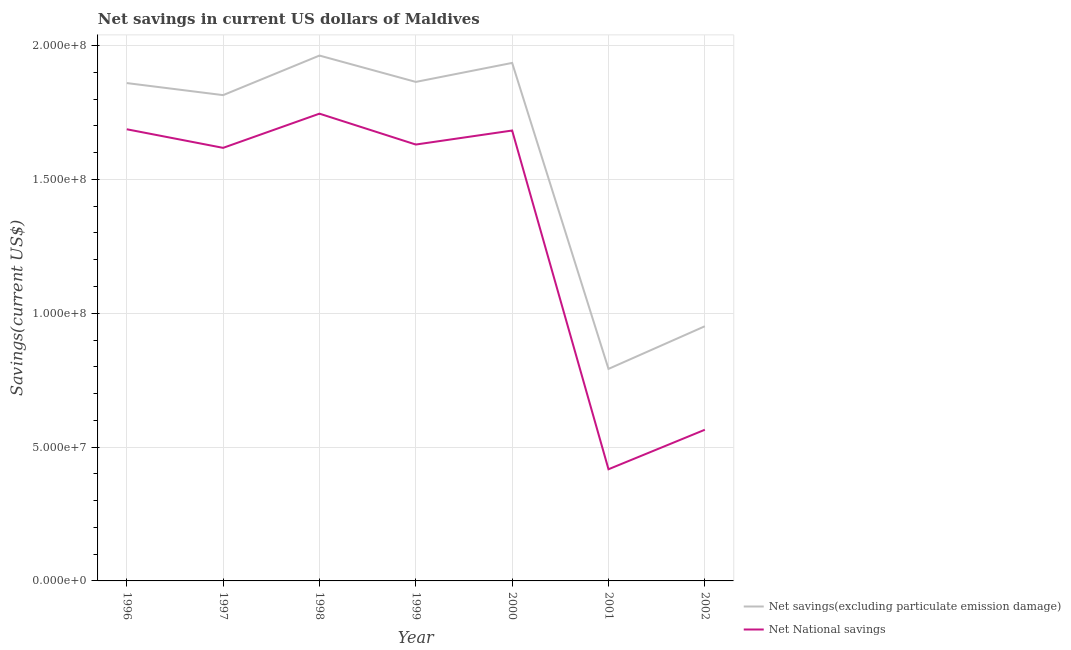Does the line corresponding to net national savings intersect with the line corresponding to net savings(excluding particulate emission damage)?
Offer a very short reply. No. What is the net national savings in 2001?
Offer a very short reply. 4.17e+07. Across all years, what is the maximum net national savings?
Make the answer very short. 1.75e+08. Across all years, what is the minimum net savings(excluding particulate emission damage)?
Your response must be concise. 7.92e+07. What is the total net savings(excluding particulate emission damage) in the graph?
Your answer should be very brief. 1.12e+09. What is the difference between the net savings(excluding particulate emission damage) in 1998 and that in 2000?
Provide a short and direct response. 2.75e+06. What is the difference between the net national savings in 2002 and the net savings(excluding particulate emission damage) in 1999?
Provide a succinct answer. -1.30e+08. What is the average net national savings per year?
Offer a terse response. 1.34e+08. In the year 2000, what is the difference between the net national savings and net savings(excluding particulate emission damage)?
Keep it short and to the point. -2.53e+07. In how many years, is the net national savings greater than 60000000 US$?
Offer a terse response. 5. What is the ratio of the net savings(excluding particulate emission damage) in 1996 to that in 2001?
Offer a very short reply. 2.35. Is the net national savings in 1996 less than that in 1999?
Ensure brevity in your answer.  No. What is the difference between the highest and the second highest net savings(excluding particulate emission damage)?
Your answer should be very brief. 2.75e+06. What is the difference between the highest and the lowest net national savings?
Ensure brevity in your answer.  1.33e+08. In how many years, is the net savings(excluding particulate emission damage) greater than the average net savings(excluding particulate emission damage) taken over all years?
Keep it short and to the point. 5. Does the net savings(excluding particulate emission damage) monotonically increase over the years?
Your answer should be very brief. No. How many years are there in the graph?
Ensure brevity in your answer.  7. What is the difference between two consecutive major ticks on the Y-axis?
Keep it short and to the point. 5.00e+07. Are the values on the major ticks of Y-axis written in scientific E-notation?
Your answer should be very brief. Yes. Does the graph contain any zero values?
Keep it short and to the point. No. Where does the legend appear in the graph?
Keep it short and to the point. Bottom right. How are the legend labels stacked?
Your response must be concise. Vertical. What is the title of the graph?
Make the answer very short. Net savings in current US dollars of Maldives. What is the label or title of the Y-axis?
Your response must be concise. Savings(current US$). What is the Savings(current US$) in Net savings(excluding particulate emission damage) in 1996?
Your response must be concise. 1.86e+08. What is the Savings(current US$) of Net National savings in 1996?
Your answer should be compact. 1.69e+08. What is the Savings(current US$) of Net savings(excluding particulate emission damage) in 1997?
Offer a terse response. 1.81e+08. What is the Savings(current US$) of Net National savings in 1997?
Provide a short and direct response. 1.62e+08. What is the Savings(current US$) in Net savings(excluding particulate emission damage) in 1998?
Your answer should be very brief. 1.96e+08. What is the Savings(current US$) in Net National savings in 1998?
Offer a terse response. 1.75e+08. What is the Savings(current US$) of Net savings(excluding particulate emission damage) in 1999?
Your answer should be compact. 1.86e+08. What is the Savings(current US$) of Net National savings in 1999?
Provide a succinct answer. 1.63e+08. What is the Savings(current US$) of Net savings(excluding particulate emission damage) in 2000?
Provide a short and direct response. 1.94e+08. What is the Savings(current US$) in Net National savings in 2000?
Make the answer very short. 1.68e+08. What is the Savings(current US$) in Net savings(excluding particulate emission damage) in 2001?
Provide a short and direct response. 7.92e+07. What is the Savings(current US$) in Net National savings in 2001?
Your response must be concise. 4.17e+07. What is the Savings(current US$) of Net savings(excluding particulate emission damage) in 2002?
Provide a succinct answer. 9.51e+07. What is the Savings(current US$) of Net National savings in 2002?
Make the answer very short. 5.65e+07. Across all years, what is the maximum Savings(current US$) in Net savings(excluding particulate emission damage)?
Provide a short and direct response. 1.96e+08. Across all years, what is the maximum Savings(current US$) of Net National savings?
Your answer should be very brief. 1.75e+08. Across all years, what is the minimum Savings(current US$) in Net savings(excluding particulate emission damage)?
Offer a very short reply. 7.92e+07. Across all years, what is the minimum Savings(current US$) in Net National savings?
Offer a very short reply. 4.17e+07. What is the total Savings(current US$) in Net savings(excluding particulate emission damage) in the graph?
Your answer should be compact. 1.12e+09. What is the total Savings(current US$) of Net National savings in the graph?
Your response must be concise. 9.35e+08. What is the difference between the Savings(current US$) of Net savings(excluding particulate emission damage) in 1996 and that in 1997?
Keep it short and to the point. 4.51e+06. What is the difference between the Savings(current US$) of Net National savings in 1996 and that in 1997?
Your response must be concise. 6.95e+06. What is the difference between the Savings(current US$) of Net savings(excluding particulate emission damage) in 1996 and that in 1998?
Offer a very short reply. -1.03e+07. What is the difference between the Savings(current US$) in Net National savings in 1996 and that in 1998?
Your response must be concise. -5.83e+06. What is the difference between the Savings(current US$) of Net savings(excluding particulate emission damage) in 1996 and that in 1999?
Your answer should be compact. -4.30e+05. What is the difference between the Savings(current US$) in Net National savings in 1996 and that in 1999?
Give a very brief answer. 5.71e+06. What is the difference between the Savings(current US$) of Net savings(excluding particulate emission damage) in 1996 and that in 2000?
Your answer should be compact. -7.53e+06. What is the difference between the Savings(current US$) in Net National savings in 1996 and that in 2000?
Give a very brief answer. 4.69e+05. What is the difference between the Savings(current US$) in Net savings(excluding particulate emission damage) in 1996 and that in 2001?
Provide a short and direct response. 1.07e+08. What is the difference between the Savings(current US$) in Net National savings in 1996 and that in 2001?
Offer a very short reply. 1.27e+08. What is the difference between the Savings(current US$) in Net savings(excluding particulate emission damage) in 1996 and that in 2002?
Make the answer very short. 9.08e+07. What is the difference between the Savings(current US$) in Net National savings in 1996 and that in 2002?
Offer a terse response. 1.12e+08. What is the difference between the Savings(current US$) in Net savings(excluding particulate emission damage) in 1997 and that in 1998?
Provide a short and direct response. -1.48e+07. What is the difference between the Savings(current US$) of Net National savings in 1997 and that in 1998?
Ensure brevity in your answer.  -1.28e+07. What is the difference between the Savings(current US$) in Net savings(excluding particulate emission damage) in 1997 and that in 1999?
Your answer should be very brief. -4.94e+06. What is the difference between the Savings(current US$) of Net National savings in 1997 and that in 1999?
Offer a terse response. -1.24e+06. What is the difference between the Savings(current US$) of Net savings(excluding particulate emission damage) in 1997 and that in 2000?
Offer a very short reply. -1.20e+07. What is the difference between the Savings(current US$) in Net National savings in 1997 and that in 2000?
Keep it short and to the point. -6.48e+06. What is the difference between the Savings(current US$) of Net savings(excluding particulate emission damage) in 1997 and that in 2001?
Keep it short and to the point. 1.02e+08. What is the difference between the Savings(current US$) of Net National savings in 1997 and that in 2001?
Provide a short and direct response. 1.20e+08. What is the difference between the Savings(current US$) of Net savings(excluding particulate emission damage) in 1997 and that in 2002?
Your answer should be very brief. 8.63e+07. What is the difference between the Savings(current US$) of Net National savings in 1997 and that in 2002?
Your answer should be very brief. 1.05e+08. What is the difference between the Savings(current US$) of Net savings(excluding particulate emission damage) in 1998 and that in 1999?
Your response must be concise. 9.85e+06. What is the difference between the Savings(current US$) of Net National savings in 1998 and that in 1999?
Provide a succinct answer. 1.15e+07. What is the difference between the Savings(current US$) of Net savings(excluding particulate emission damage) in 1998 and that in 2000?
Offer a very short reply. 2.75e+06. What is the difference between the Savings(current US$) in Net National savings in 1998 and that in 2000?
Your answer should be compact. 6.30e+06. What is the difference between the Savings(current US$) of Net savings(excluding particulate emission damage) in 1998 and that in 2001?
Give a very brief answer. 1.17e+08. What is the difference between the Savings(current US$) in Net National savings in 1998 and that in 2001?
Provide a succinct answer. 1.33e+08. What is the difference between the Savings(current US$) of Net savings(excluding particulate emission damage) in 1998 and that in 2002?
Your response must be concise. 1.01e+08. What is the difference between the Savings(current US$) of Net National savings in 1998 and that in 2002?
Your answer should be compact. 1.18e+08. What is the difference between the Savings(current US$) in Net savings(excluding particulate emission damage) in 1999 and that in 2000?
Your answer should be very brief. -7.10e+06. What is the difference between the Savings(current US$) of Net National savings in 1999 and that in 2000?
Provide a succinct answer. -5.24e+06. What is the difference between the Savings(current US$) in Net savings(excluding particulate emission damage) in 1999 and that in 2001?
Give a very brief answer. 1.07e+08. What is the difference between the Savings(current US$) of Net National savings in 1999 and that in 2001?
Offer a very short reply. 1.21e+08. What is the difference between the Savings(current US$) of Net savings(excluding particulate emission damage) in 1999 and that in 2002?
Offer a very short reply. 9.13e+07. What is the difference between the Savings(current US$) in Net National savings in 1999 and that in 2002?
Your response must be concise. 1.07e+08. What is the difference between the Savings(current US$) of Net savings(excluding particulate emission damage) in 2000 and that in 2001?
Your answer should be compact. 1.14e+08. What is the difference between the Savings(current US$) in Net National savings in 2000 and that in 2001?
Your response must be concise. 1.27e+08. What is the difference between the Savings(current US$) of Net savings(excluding particulate emission damage) in 2000 and that in 2002?
Make the answer very short. 9.84e+07. What is the difference between the Savings(current US$) in Net National savings in 2000 and that in 2002?
Offer a terse response. 1.12e+08. What is the difference between the Savings(current US$) of Net savings(excluding particulate emission damage) in 2001 and that in 2002?
Your answer should be very brief. -1.59e+07. What is the difference between the Savings(current US$) in Net National savings in 2001 and that in 2002?
Your answer should be compact. -1.48e+07. What is the difference between the Savings(current US$) in Net savings(excluding particulate emission damage) in 1996 and the Savings(current US$) in Net National savings in 1997?
Ensure brevity in your answer.  2.42e+07. What is the difference between the Savings(current US$) in Net savings(excluding particulate emission damage) in 1996 and the Savings(current US$) in Net National savings in 1998?
Ensure brevity in your answer.  1.14e+07. What is the difference between the Savings(current US$) in Net savings(excluding particulate emission damage) in 1996 and the Savings(current US$) in Net National savings in 1999?
Provide a short and direct response. 2.30e+07. What is the difference between the Savings(current US$) of Net savings(excluding particulate emission damage) in 1996 and the Savings(current US$) of Net National savings in 2000?
Your response must be concise. 1.77e+07. What is the difference between the Savings(current US$) of Net savings(excluding particulate emission damage) in 1996 and the Savings(current US$) of Net National savings in 2001?
Provide a short and direct response. 1.44e+08. What is the difference between the Savings(current US$) in Net savings(excluding particulate emission damage) in 1996 and the Savings(current US$) in Net National savings in 2002?
Provide a succinct answer. 1.30e+08. What is the difference between the Savings(current US$) in Net savings(excluding particulate emission damage) in 1997 and the Savings(current US$) in Net National savings in 1998?
Offer a very short reply. 6.92e+06. What is the difference between the Savings(current US$) of Net savings(excluding particulate emission damage) in 1997 and the Savings(current US$) of Net National savings in 1999?
Offer a terse response. 1.85e+07. What is the difference between the Savings(current US$) of Net savings(excluding particulate emission damage) in 1997 and the Savings(current US$) of Net National savings in 2000?
Your response must be concise. 1.32e+07. What is the difference between the Savings(current US$) in Net savings(excluding particulate emission damage) in 1997 and the Savings(current US$) in Net National savings in 2001?
Your answer should be very brief. 1.40e+08. What is the difference between the Savings(current US$) in Net savings(excluding particulate emission damage) in 1997 and the Savings(current US$) in Net National savings in 2002?
Your answer should be very brief. 1.25e+08. What is the difference between the Savings(current US$) in Net savings(excluding particulate emission damage) in 1998 and the Savings(current US$) in Net National savings in 1999?
Keep it short and to the point. 3.32e+07. What is the difference between the Savings(current US$) in Net savings(excluding particulate emission damage) in 1998 and the Savings(current US$) in Net National savings in 2000?
Ensure brevity in your answer.  2.80e+07. What is the difference between the Savings(current US$) in Net savings(excluding particulate emission damage) in 1998 and the Savings(current US$) in Net National savings in 2001?
Give a very brief answer. 1.55e+08. What is the difference between the Savings(current US$) in Net savings(excluding particulate emission damage) in 1998 and the Savings(current US$) in Net National savings in 2002?
Offer a very short reply. 1.40e+08. What is the difference between the Savings(current US$) in Net savings(excluding particulate emission damage) in 1999 and the Savings(current US$) in Net National savings in 2000?
Your answer should be compact. 1.82e+07. What is the difference between the Savings(current US$) of Net savings(excluding particulate emission damage) in 1999 and the Savings(current US$) of Net National savings in 2001?
Make the answer very short. 1.45e+08. What is the difference between the Savings(current US$) in Net savings(excluding particulate emission damage) in 1999 and the Savings(current US$) in Net National savings in 2002?
Make the answer very short. 1.30e+08. What is the difference between the Savings(current US$) in Net savings(excluding particulate emission damage) in 2000 and the Savings(current US$) in Net National savings in 2001?
Your response must be concise. 1.52e+08. What is the difference between the Savings(current US$) in Net savings(excluding particulate emission damage) in 2000 and the Savings(current US$) in Net National savings in 2002?
Offer a very short reply. 1.37e+08. What is the difference between the Savings(current US$) of Net savings(excluding particulate emission damage) in 2001 and the Savings(current US$) of Net National savings in 2002?
Offer a terse response. 2.27e+07. What is the average Savings(current US$) in Net savings(excluding particulate emission damage) per year?
Offer a very short reply. 1.60e+08. What is the average Savings(current US$) of Net National savings per year?
Offer a very short reply. 1.34e+08. In the year 1996, what is the difference between the Savings(current US$) in Net savings(excluding particulate emission damage) and Savings(current US$) in Net National savings?
Keep it short and to the point. 1.73e+07. In the year 1997, what is the difference between the Savings(current US$) in Net savings(excluding particulate emission damage) and Savings(current US$) in Net National savings?
Your answer should be compact. 1.97e+07. In the year 1998, what is the difference between the Savings(current US$) of Net savings(excluding particulate emission damage) and Savings(current US$) of Net National savings?
Offer a very short reply. 2.17e+07. In the year 1999, what is the difference between the Savings(current US$) in Net savings(excluding particulate emission damage) and Savings(current US$) in Net National savings?
Keep it short and to the point. 2.34e+07. In the year 2000, what is the difference between the Savings(current US$) of Net savings(excluding particulate emission damage) and Savings(current US$) of Net National savings?
Ensure brevity in your answer.  2.53e+07. In the year 2001, what is the difference between the Savings(current US$) of Net savings(excluding particulate emission damage) and Savings(current US$) of Net National savings?
Provide a succinct answer. 3.75e+07. In the year 2002, what is the difference between the Savings(current US$) of Net savings(excluding particulate emission damage) and Savings(current US$) of Net National savings?
Provide a short and direct response. 3.87e+07. What is the ratio of the Savings(current US$) in Net savings(excluding particulate emission damage) in 1996 to that in 1997?
Your answer should be compact. 1.02. What is the ratio of the Savings(current US$) in Net National savings in 1996 to that in 1997?
Your response must be concise. 1.04. What is the ratio of the Savings(current US$) in Net savings(excluding particulate emission damage) in 1996 to that in 1998?
Make the answer very short. 0.95. What is the ratio of the Savings(current US$) in Net National savings in 1996 to that in 1998?
Give a very brief answer. 0.97. What is the ratio of the Savings(current US$) in Net savings(excluding particulate emission damage) in 1996 to that in 1999?
Keep it short and to the point. 1. What is the ratio of the Savings(current US$) in Net National savings in 1996 to that in 1999?
Ensure brevity in your answer.  1.03. What is the ratio of the Savings(current US$) in Net savings(excluding particulate emission damage) in 1996 to that in 2000?
Make the answer very short. 0.96. What is the ratio of the Savings(current US$) of Net savings(excluding particulate emission damage) in 1996 to that in 2001?
Give a very brief answer. 2.35. What is the ratio of the Savings(current US$) in Net National savings in 1996 to that in 2001?
Your response must be concise. 4.04. What is the ratio of the Savings(current US$) of Net savings(excluding particulate emission damage) in 1996 to that in 2002?
Offer a very short reply. 1.95. What is the ratio of the Savings(current US$) of Net National savings in 1996 to that in 2002?
Keep it short and to the point. 2.99. What is the ratio of the Savings(current US$) of Net savings(excluding particulate emission damage) in 1997 to that in 1998?
Your answer should be compact. 0.92. What is the ratio of the Savings(current US$) of Net National savings in 1997 to that in 1998?
Give a very brief answer. 0.93. What is the ratio of the Savings(current US$) in Net savings(excluding particulate emission damage) in 1997 to that in 1999?
Ensure brevity in your answer.  0.97. What is the ratio of the Savings(current US$) of Net National savings in 1997 to that in 1999?
Keep it short and to the point. 0.99. What is the ratio of the Savings(current US$) in Net savings(excluding particulate emission damage) in 1997 to that in 2000?
Your response must be concise. 0.94. What is the ratio of the Savings(current US$) of Net National savings in 1997 to that in 2000?
Your answer should be compact. 0.96. What is the ratio of the Savings(current US$) in Net savings(excluding particulate emission damage) in 1997 to that in 2001?
Provide a succinct answer. 2.29. What is the ratio of the Savings(current US$) in Net National savings in 1997 to that in 2001?
Provide a succinct answer. 3.88. What is the ratio of the Savings(current US$) in Net savings(excluding particulate emission damage) in 1997 to that in 2002?
Give a very brief answer. 1.91. What is the ratio of the Savings(current US$) of Net National savings in 1997 to that in 2002?
Keep it short and to the point. 2.86. What is the ratio of the Savings(current US$) of Net savings(excluding particulate emission damage) in 1998 to that in 1999?
Give a very brief answer. 1.05. What is the ratio of the Savings(current US$) of Net National savings in 1998 to that in 1999?
Your answer should be compact. 1.07. What is the ratio of the Savings(current US$) of Net savings(excluding particulate emission damage) in 1998 to that in 2000?
Keep it short and to the point. 1.01. What is the ratio of the Savings(current US$) in Net National savings in 1998 to that in 2000?
Provide a succinct answer. 1.04. What is the ratio of the Savings(current US$) in Net savings(excluding particulate emission damage) in 1998 to that in 2001?
Offer a terse response. 2.48. What is the ratio of the Savings(current US$) of Net National savings in 1998 to that in 2001?
Your answer should be compact. 4.18. What is the ratio of the Savings(current US$) of Net savings(excluding particulate emission damage) in 1998 to that in 2002?
Your answer should be very brief. 2.06. What is the ratio of the Savings(current US$) of Net National savings in 1998 to that in 2002?
Your answer should be very brief. 3.09. What is the ratio of the Savings(current US$) in Net savings(excluding particulate emission damage) in 1999 to that in 2000?
Keep it short and to the point. 0.96. What is the ratio of the Savings(current US$) of Net National savings in 1999 to that in 2000?
Your answer should be very brief. 0.97. What is the ratio of the Savings(current US$) in Net savings(excluding particulate emission damage) in 1999 to that in 2001?
Make the answer very short. 2.35. What is the ratio of the Savings(current US$) of Net National savings in 1999 to that in 2001?
Offer a terse response. 3.91. What is the ratio of the Savings(current US$) of Net savings(excluding particulate emission damage) in 1999 to that in 2002?
Offer a very short reply. 1.96. What is the ratio of the Savings(current US$) in Net National savings in 1999 to that in 2002?
Offer a terse response. 2.89. What is the ratio of the Savings(current US$) in Net savings(excluding particulate emission damage) in 2000 to that in 2001?
Keep it short and to the point. 2.44. What is the ratio of the Savings(current US$) of Net National savings in 2000 to that in 2001?
Your answer should be compact. 4.03. What is the ratio of the Savings(current US$) in Net savings(excluding particulate emission damage) in 2000 to that in 2002?
Provide a succinct answer. 2.03. What is the ratio of the Savings(current US$) in Net National savings in 2000 to that in 2002?
Ensure brevity in your answer.  2.98. What is the ratio of the Savings(current US$) of Net savings(excluding particulate emission damage) in 2001 to that in 2002?
Offer a very short reply. 0.83. What is the ratio of the Savings(current US$) in Net National savings in 2001 to that in 2002?
Give a very brief answer. 0.74. What is the difference between the highest and the second highest Savings(current US$) in Net savings(excluding particulate emission damage)?
Your response must be concise. 2.75e+06. What is the difference between the highest and the second highest Savings(current US$) of Net National savings?
Make the answer very short. 5.83e+06. What is the difference between the highest and the lowest Savings(current US$) of Net savings(excluding particulate emission damage)?
Ensure brevity in your answer.  1.17e+08. What is the difference between the highest and the lowest Savings(current US$) of Net National savings?
Your answer should be very brief. 1.33e+08. 